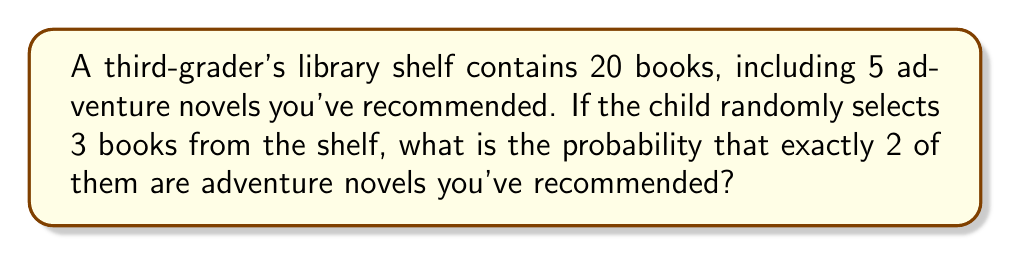Show me your answer to this math problem. Let's approach this step-by-step using the hypergeometric distribution:

1) We have:
   - Total books: $n = 20$
   - Adventure novels recommended: $k = 5$
   - Books selected: $r = 3$
   - We want exactly $x = 2$ adventure novels

2) The probability is calculated using the formula:

   $$P(X=x) = \frac{\binom{k}{x} \binom{n-k}{r-x}}{\binom{n}{r}}$$

3) Let's calculate each combination:

   $\binom{k}{x} = \binom{5}{2} = 10$
   $\binom{n-k}{r-x} = \binom{15}{1} = 15$
   $\binom{n}{r} = \binom{20}{3} = 1140$

4) Now, let's substitute these values into our formula:

   $$P(X=2) = \frac{10 \times 15}{1140} = \frac{150}{1140}$$

5) Simplify the fraction:

   $$\frac{150}{1140} = \frac{5}{38} \approx 0.1316$$

Therefore, the probability of selecting exactly 2 adventure novels out of 3 randomly selected books is $\frac{5}{38}$ or approximately 13.16%.
Answer: $\frac{5}{38}$ 